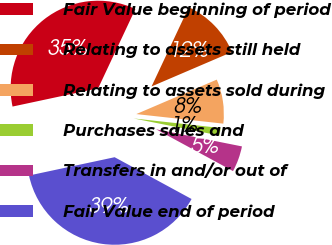Convert chart to OTSL. <chart><loc_0><loc_0><loc_500><loc_500><pie_chart><fcel>Fair Value beginning of period<fcel>Relating to assets still held<fcel>Relating to assets sold during<fcel>Purchases sales and<fcel>Transfers in and/or out of<fcel>Fair Value end of period<nl><fcel>35.34%<fcel>11.57%<fcel>8.18%<fcel>1.39%<fcel>4.79%<fcel>38.73%<nl></chart> 